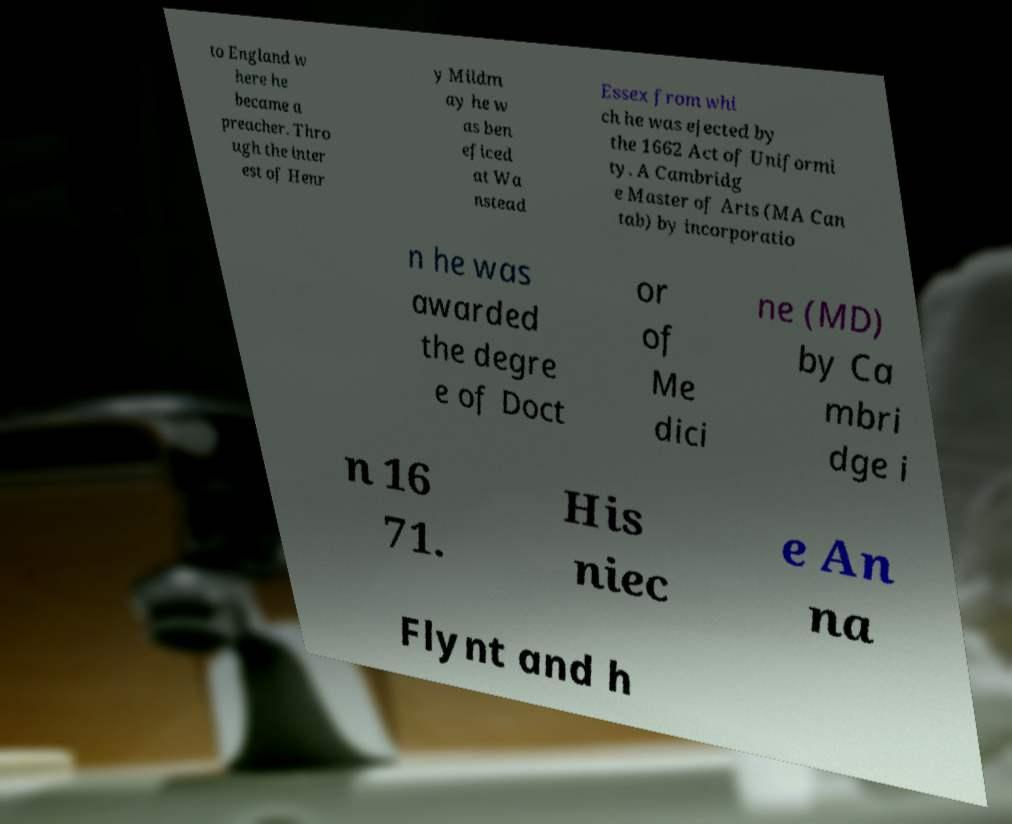What messages or text are displayed in this image? I need them in a readable, typed format. to England w here he became a preacher. Thro ugh the inter est of Henr y Mildm ay he w as ben eficed at Wa nstead Essex from whi ch he was ejected by the 1662 Act of Uniformi ty. A Cambridg e Master of Arts (MA Can tab) by incorporatio n he was awarded the degre e of Doct or of Me dici ne (MD) by Ca mbri dge i n 16 71. His niec e An na Flynt and h 